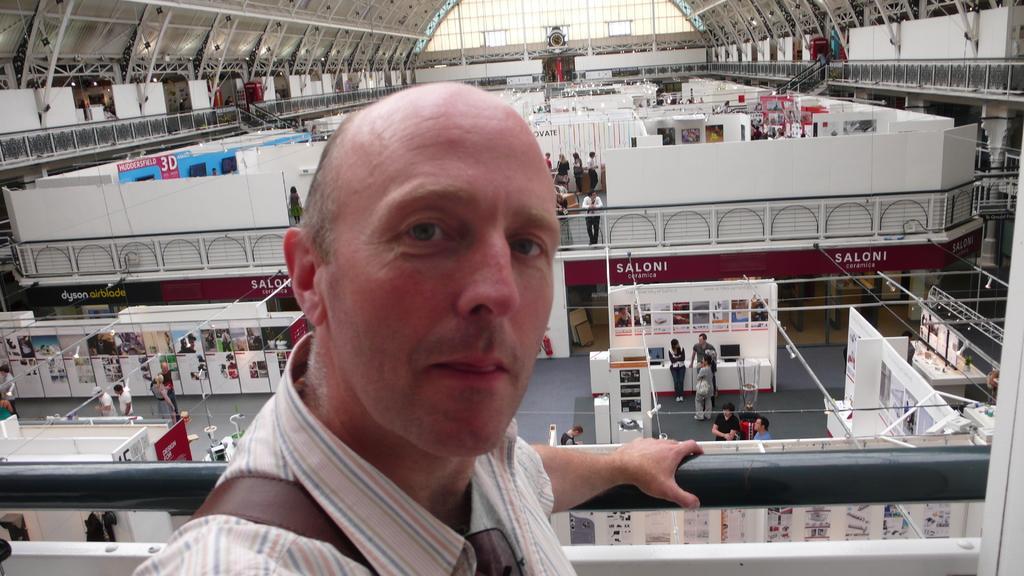In one or two sentences, can you explain what this image depicts? In this picture I can see a person, behind I can see inside of the building, few people are standing and also there are some stoles. 